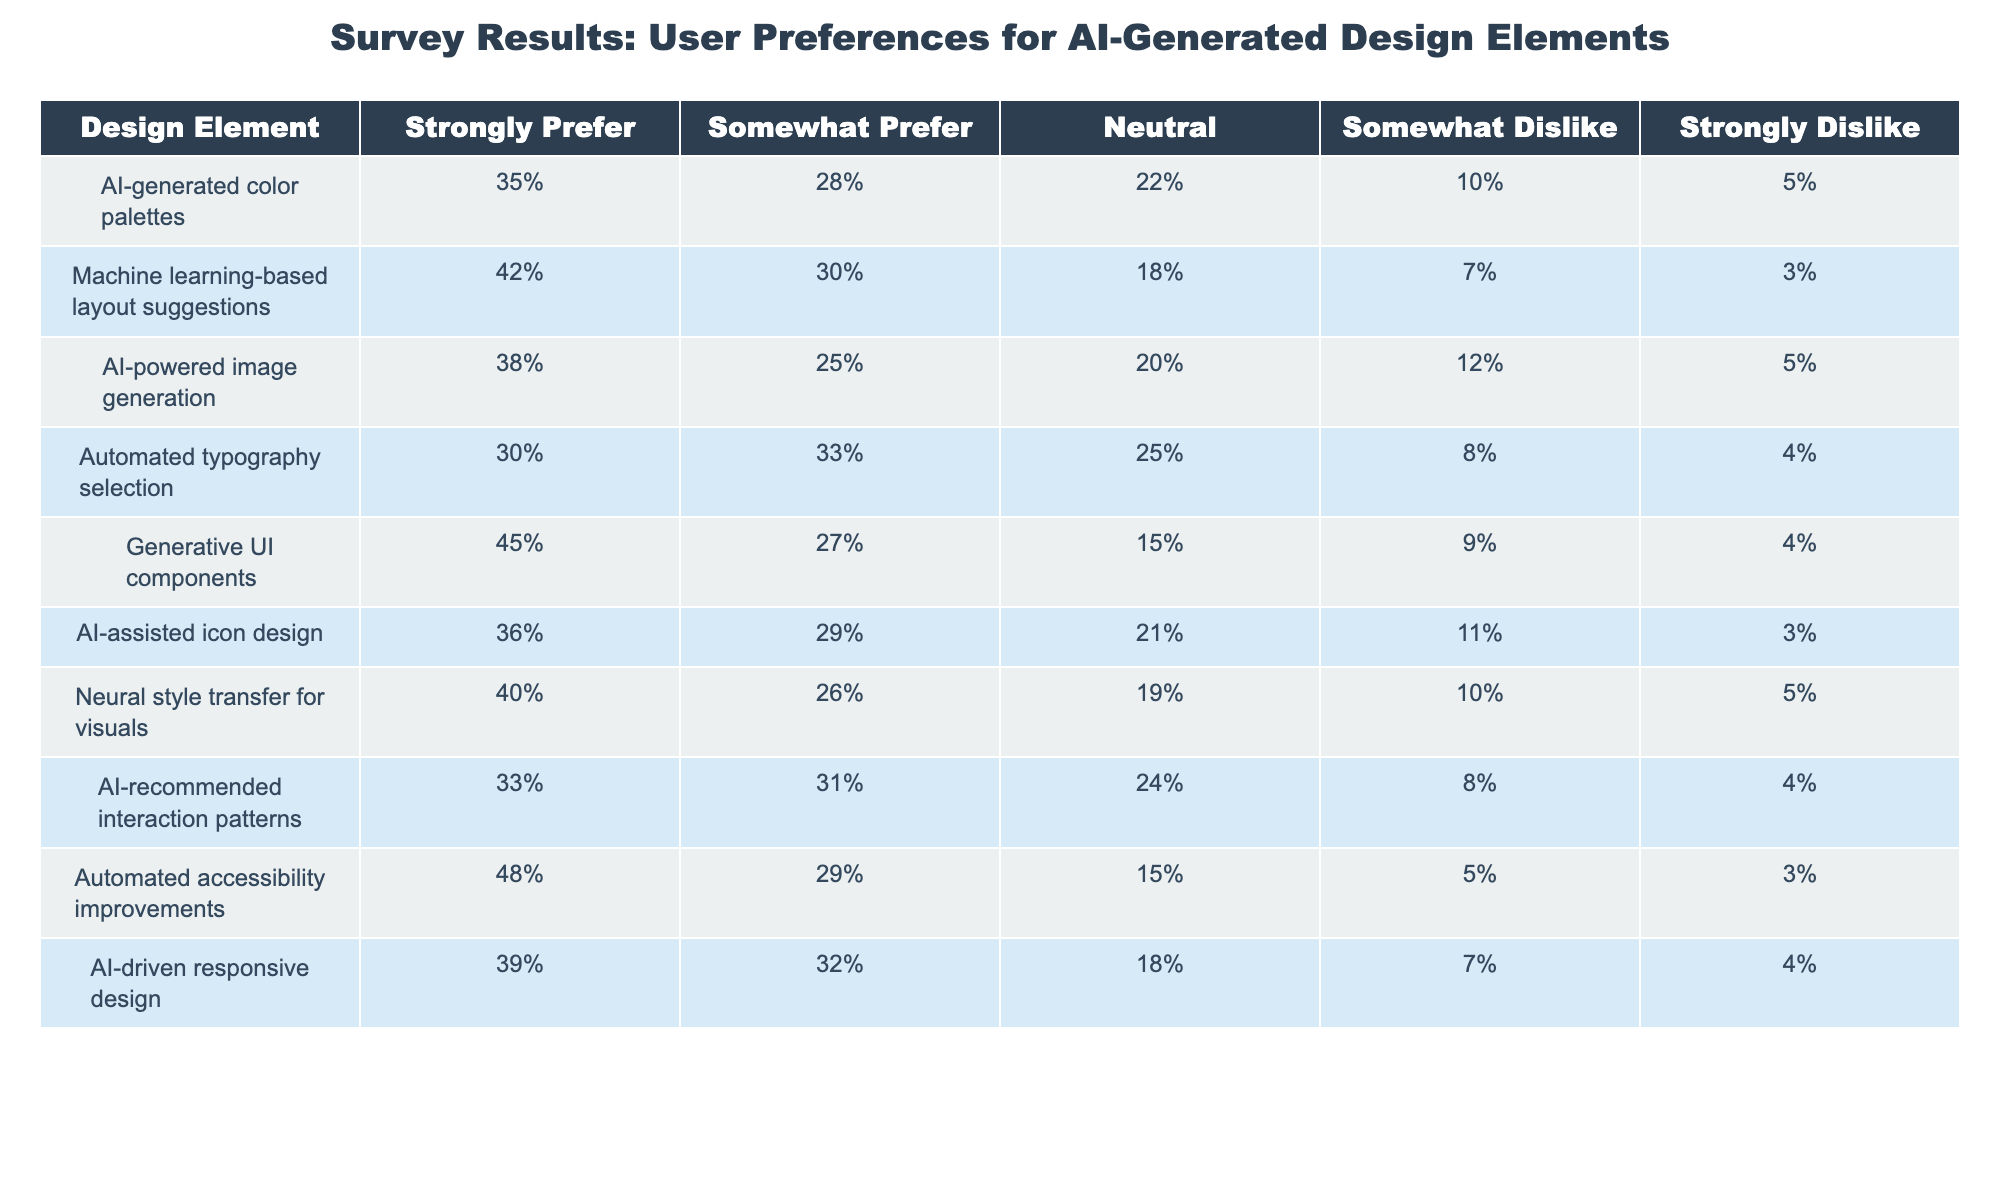What percentage of users strongly prefer automated typography selection? The table shows that 30% of users strongly prefer automated typography selection. This information is directly available in the corresponding row of the table.
Answer: 30% Which design element received the highest percentage of strong preferences? By examining each row for the "Strongly Prefer" column, generative UI components received the highest preference at 45%. Therefore, it is the design element with the most strong preferences.
Answer: Generative UI components What is the total percentage of users who either strongly prefer or somewhat prefer AI-generated color palettes? To find this, add the percentages of "Strongly Prefer" (35%) and "Somewhat Prefer" (28%) for AI-generated color palettes: 35% + 28% = 63%. This gives us the total preference percentage.
Answer: 63% Is it true that at least one design element has less than 10% of users who strongly dislike it? By reviewing the "Strongly Dislike" column, we see that both automated accessibility improvements (3%) and machine learning-based layout suggestions (3%) have strong dislike percentages below 10%. Therefore, the statement is true.
Answer: Yes What is the average percentage of users who are neutral regarding machine learning-based layout suggestions and AI-assisted icon design? The neutral percentages for these elements are 18% (machine learning-based layout suggestions) and 21% (AI-assisted icon design). To find the average, we add these two percentages (18% + 21% = 39%) and divide by the number of elements (2): 39% / 2 = 19.5%.
Answer: 19.5% What is the difference in the "Strongly Prefer" percentage between neural style transfer for visuals and AI-generated color palettes? First, find the "Strongly Prefer" percentages: 40% for neural style transfer for visuals and 35% for AI-generated color palettes. The difference is calculated by subtracting the lesser value from the greater: 40% - 35% = 5%.
Answer: 5% How many design elements have a preference rate of 40% or higher for "Strongly Prefer"? By tallying the elements in the table with "Strongly Prefer" percentages of 40% or higher, we find neural style transfer for visuals (40%), generative UI components (45%), and automated accessibility improvements (48%). This gives a total of three elements.
Answer: 3 